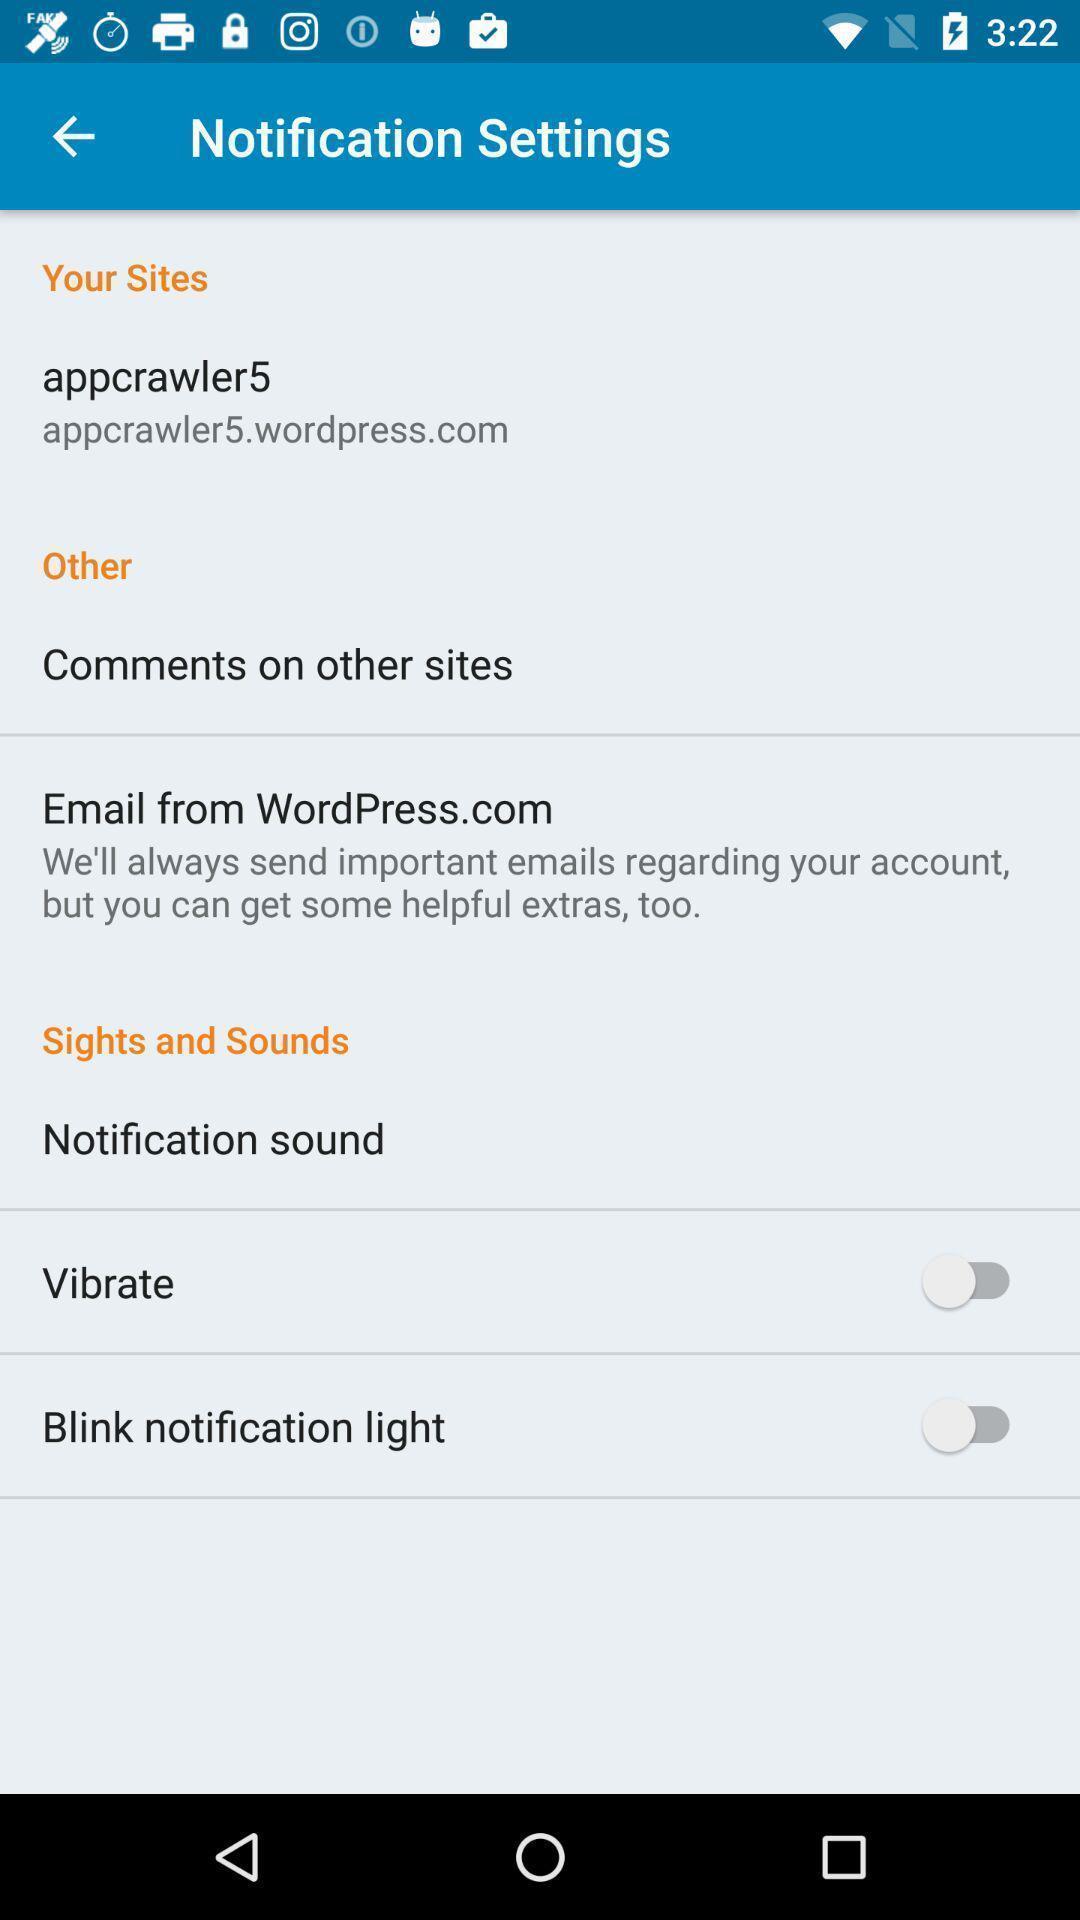Describe the content in this image. Screen displaying user information and multiple setting options. 